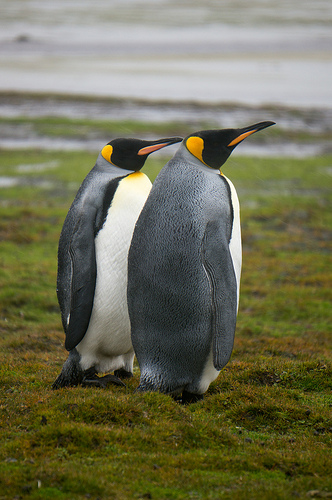<image>
Can you confirm if the beak is on the penguin? Yes. Looking at the image, I can see the beak is positioned on top of the penguin, with the penguin providing support. 